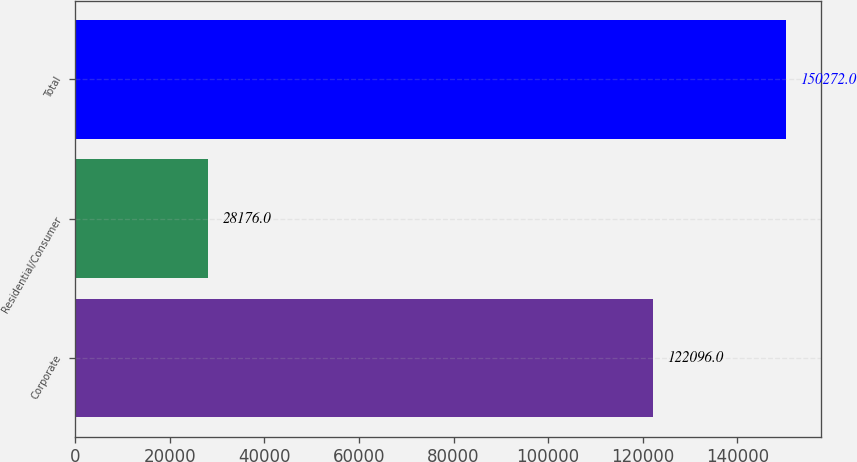Convert chart. <chart><loc_0><loc_0><loc_500><loc_500><bar_chart><fcel>Corporate<fcel>Residential/Consumer<fcel>Total<nl><fcel>122096<fcel>28176<fcel>150272<nl></chart> 